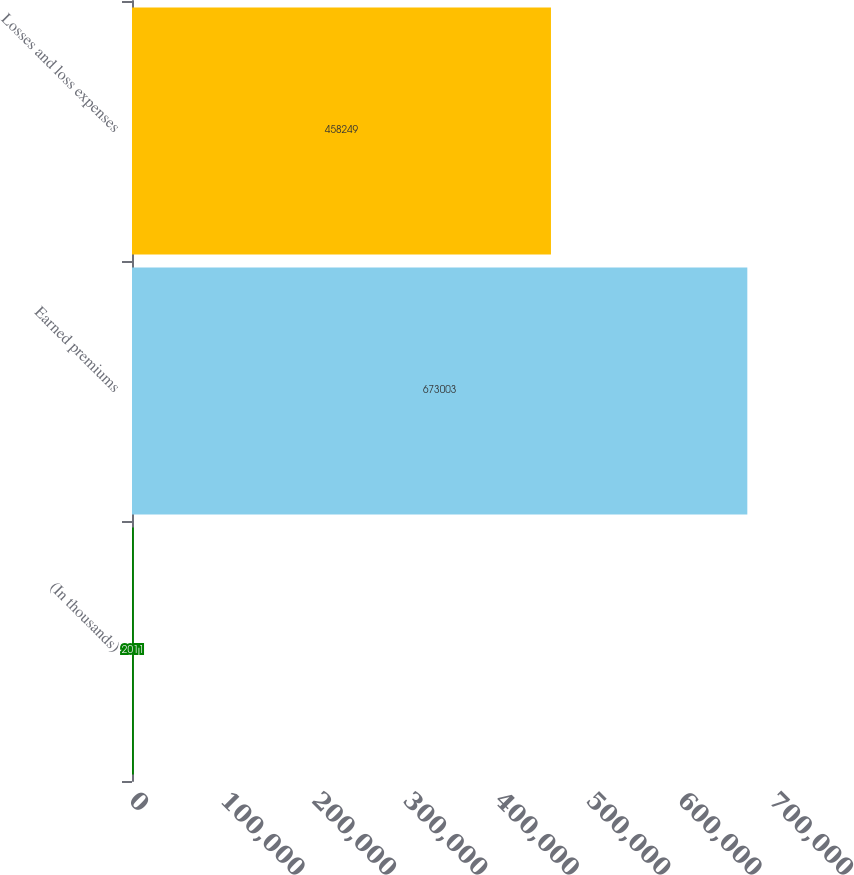<chart> <loc_0><loc_0><loc_500><loc_500><bar_chart><fcel>(In thousands)<fcel>Earned premiums<fcel>Losses and loss expenses<nl><fcel>2011<fcel>673003<fcel>458249<nl></chart> 